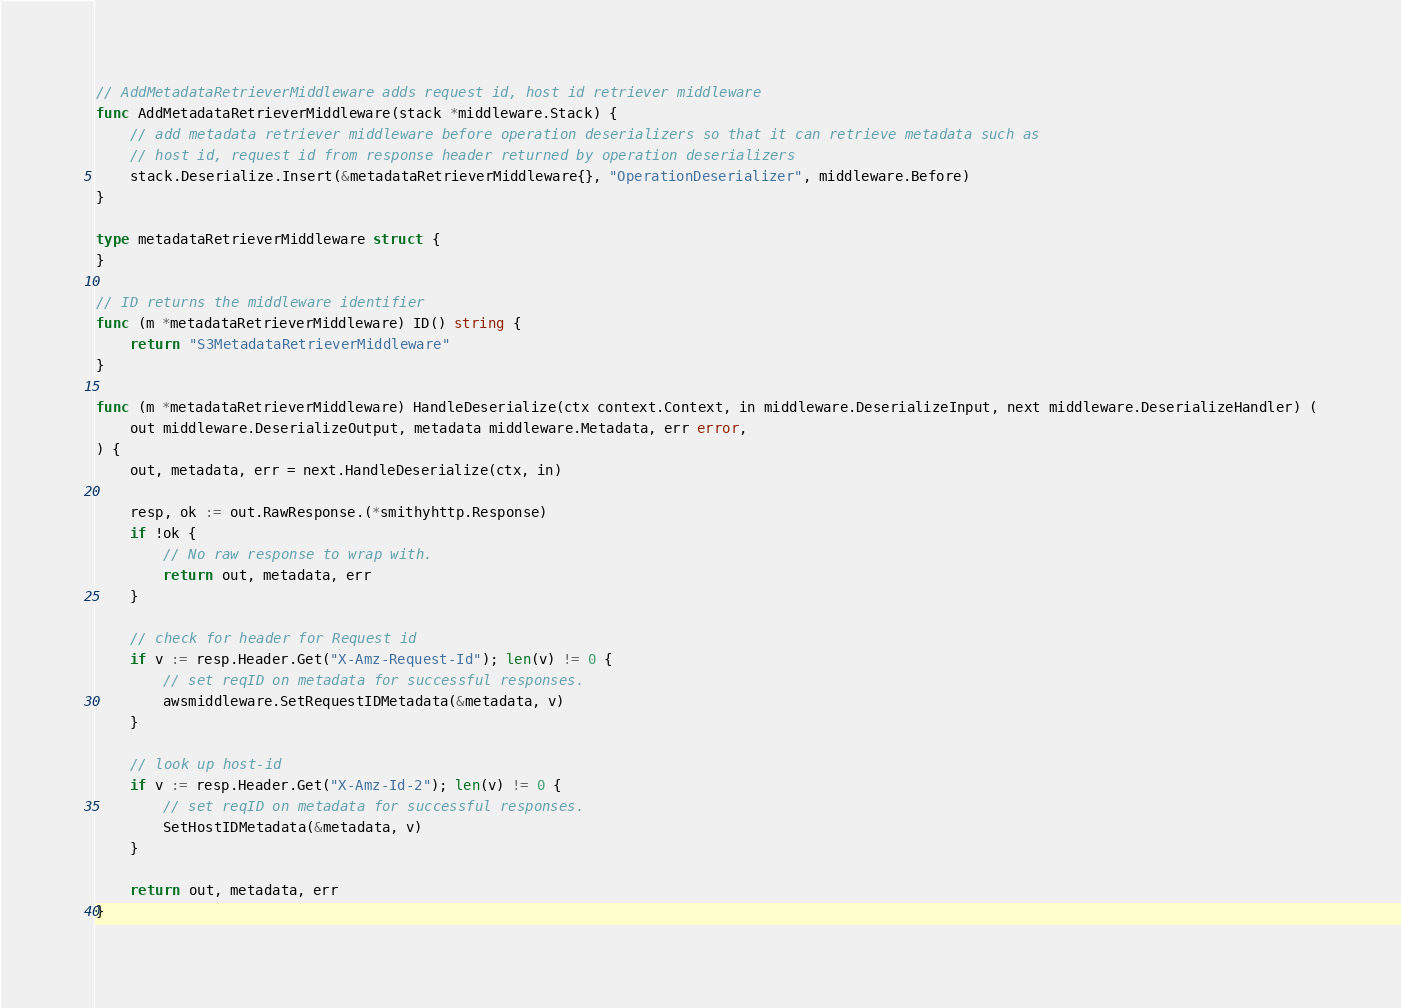<code> <loc_0><loc_0><loc_500><loc_500><_Go_>// AddMetadataRetrieverMiddleware adds request id, host id retriever middleware
func AddMetadataRetrieverMiddleware(stack *middleware.Stack) {
	// add metadata retriever middleware before operation deserializers so that it can retrieve metadata such as
	// host id, request id from response header returned by operation deserializers
	stack.Deserialize.Insert(&metadataRetrieverMiddleware{}, "OperationDeserializer", middleware.Before)
}

type metadataRetrieverMiddleware struct {
}

// ID returns the middleware identifier
func (m *metadataRetrieverMiddleware) ID() string {
	return "S3MetadataRetrieverMiddleware"
}

func (m *metadataRetrieverMiddleware) HandleDeserialize(ctx context.Context, in middleware.DeserializeInput, next middleware.DeserializeHandler) (
	out middleware.DeserializeOutput, metadata middleware.Metadata, err error,
) {
	out, metadata, err = next.HandleDeserialize(ctx, in)

	resp, ok := out.RawResponse.(*smithyhttp.Response)
	if !ok {
		// No raw response to wrap with.
		return out, metadata, err
	}

	// check for header for Request id
	if v := resp.Header.Get("X-Amz-Request-Id"); len(v) != 0 {
		// set reqID on metadata for successful responses.
		awsmiddleware.SetRequestIDMetadata(&metadata, v)
	}

	// look up host-id
	if v := resp.Header.Get("X-Amz-Id-2"); len(v) != 0 {
		// set reqID on metadata for successful responses.
		SetHostIDMetadata(&metadata, v)
	}

	return out, metadata, err
}
</code> 